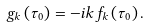<formula> <loc_0><loc_0><loc_500><loc_500>g _ { k } \left ( \tau _ { 0 } \right ) = - i k f _ { k } \left ( \tau _ { 0 } \right ) .</formula> 